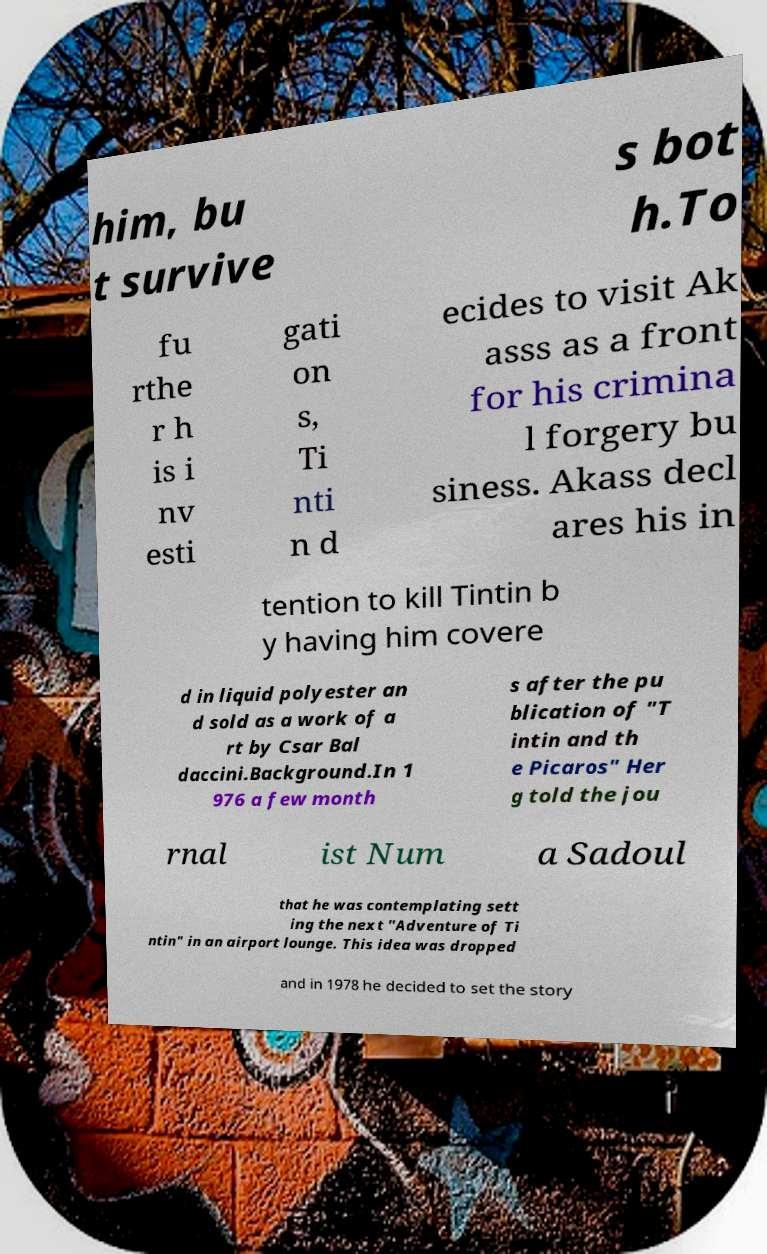For documentation purposes, I need the text within this image transcribed. Could you provide that? him, bu t survive s bot h.To fu rthe r h is i nv esti gati on s, Ti nti n d ecides to visit Ak asss as a front for his crimina l forgery bu siness. Akass decl ares his in tention to kill Tintin b y having him covere d in liquid polyester an d sold as a work of a rt by Csar Bal daccini.Background.In 1 976 a few month s after the pu blication of "T intin and th e Picaros" Her g told the jou rnal ist Num a Sadoul that he was contemplating sett ing the next "Adventure of Ti ntin" in an airport lounge. This idea was dropped and in 1978 he decided to set the story 